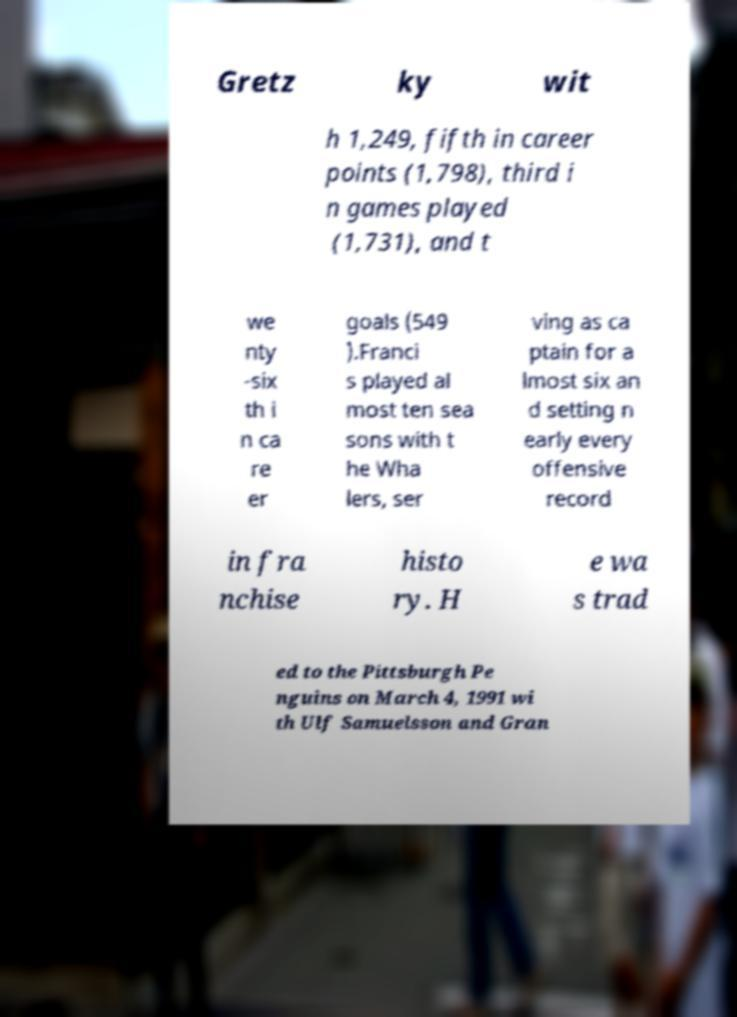Please read and relay the text visible in this image. What does it say? Gretz ky wit h 1,249, fifth in career points (1,798), third i n games played (1,731), and t we nty -six th i n ca re er goals (549 ).Franci s played al most ten sea sons with t he Wha lers, ser ving as ca ptain for a lmost six an d setting n early every offensive record in fra nchise histo ry. H e wa s trad ed to the Pittsburgh Pe nguins on March 4, 1991 wi th Ulf Samuelsson and Gran 